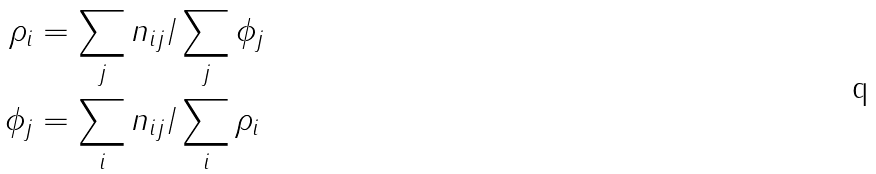Convert formula to latex. <formula><loc_0><loc_0><loc_500><loc_500>\rho _ { i } & = \sum _ { j } n _ { i j } / \sum _ { j } \phi _ { j } \\ \phi _ { j } & = \sum _ { i } n _ { i j } / \sum _ { i } \rho _ { i }</formula> 